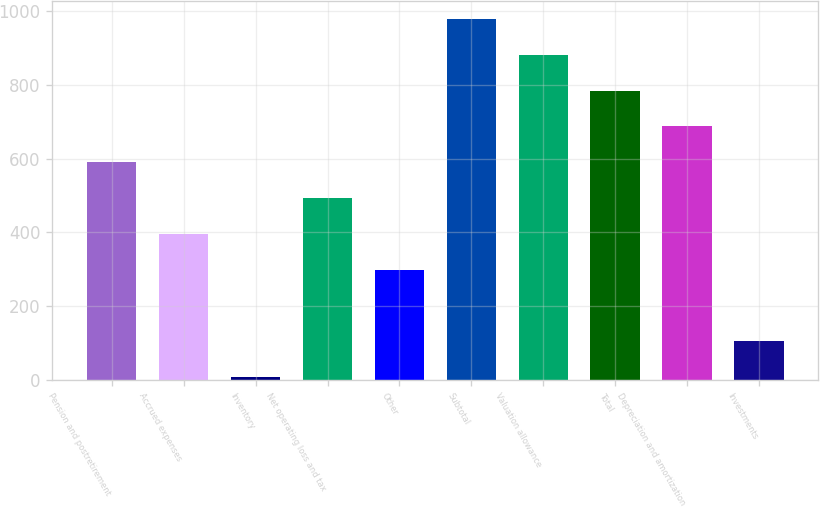Convert chart. <chart><loc_0><loc_0><loc_500><loc_500><bar_chart><fcel>Pension and postretirement<fcel>Accrued expenses<fcel>Inventory<fcel>Net operating loss and tax<fcel>Other<fcel>Subtotal<fcel>Valuation allowance<fcel>Total<fcel>Depreciation and amortization<fcel>Investments<nl><fcel>590<fcel>396<fcel>8<fcel>493<fcel>299<fcel>978<fcel>881<fcel>784<fcel>687<fcel>105<nl></chart> 